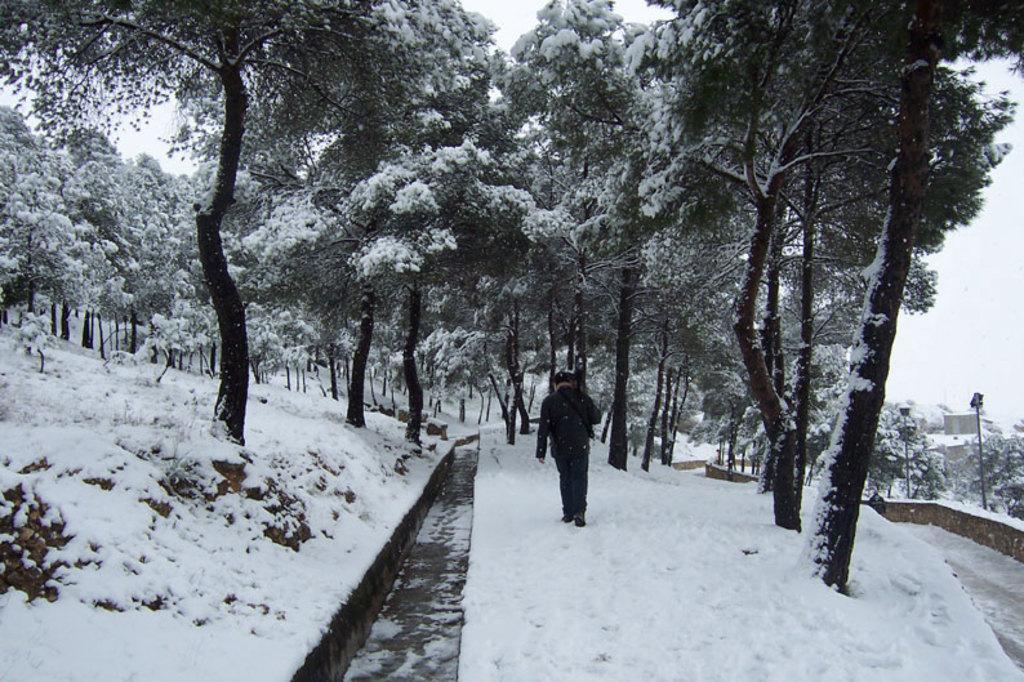How would you summarize this image in a sentence or two? In the image we can see there is a man standing on the ground and the ground is covered with snow. There are lot of trees and the trees are covered with snow. 